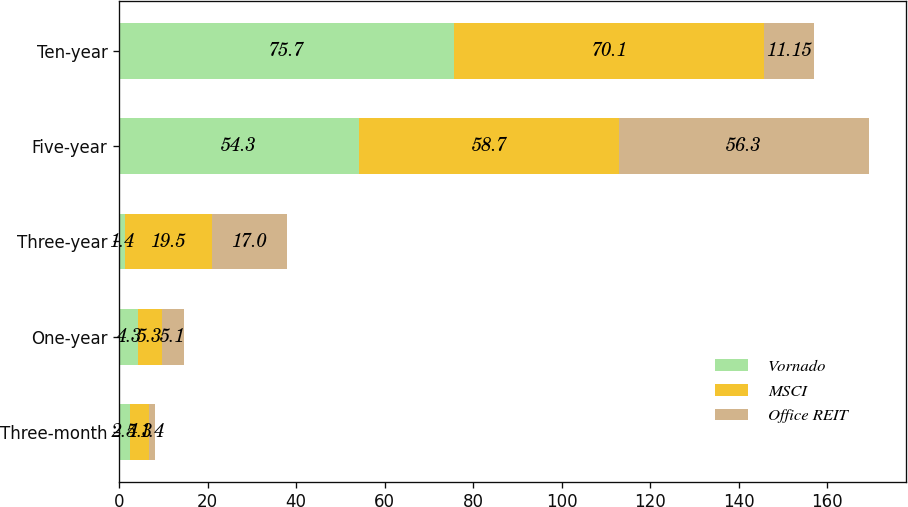Convert chart. <chart><loc_0><loc_0><loc_500><loc_500><stacked_bar_chart><ecel><fcel>Three-month<fcel>One-year<fcel>Three-year<fcel>Five-year<fcel>Ten-year<nl><fcel>Vornado<fcel>2.5<fcel>4.3<fcel>1.4<fcel>54.3<fcel>75.7<nl><fcel>MSCI<fcel>4.3<fcel>5.3<fcel>19.5<fcel>58.7<fcel>70.1<nl><fcel>Office REIT<fcel>1.4<fcel>5.1<fcel>17<fcel>56.3<fcel>11.15<nl></chart> 